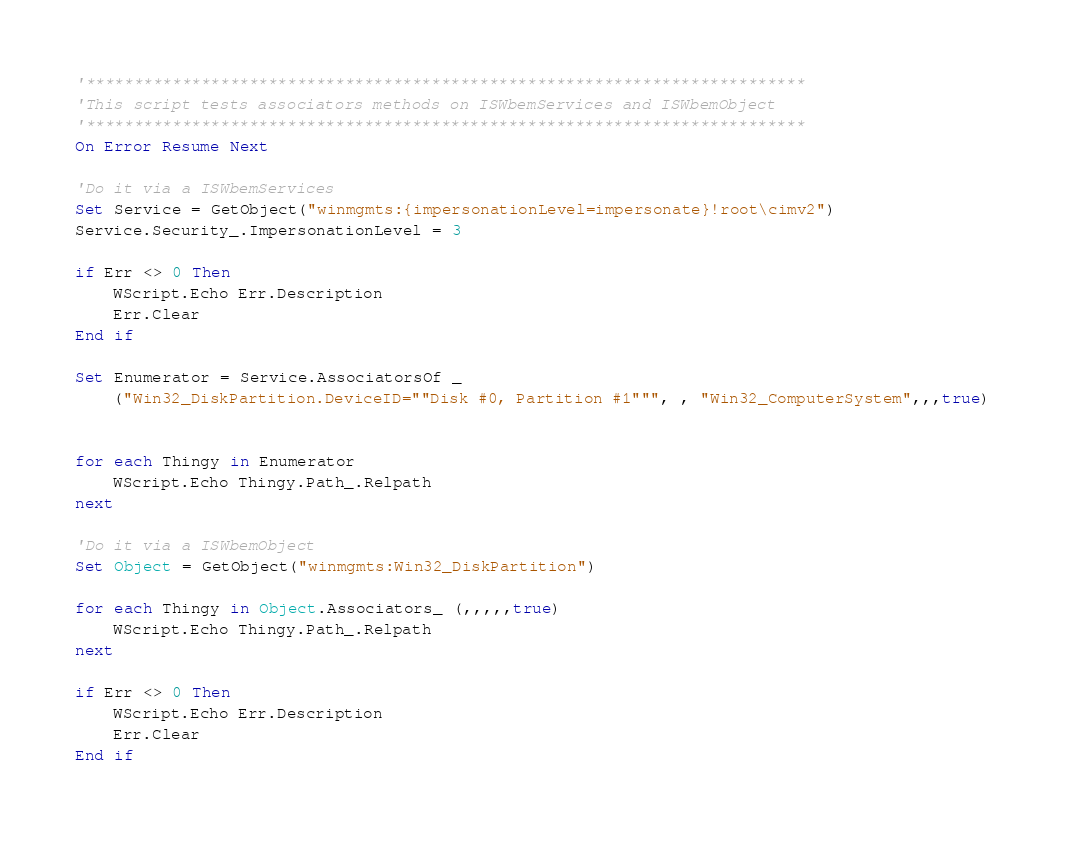<code> <loc_0><loc_0><loc_500><loc_500><_VisualBasic_>'***************************************************************************
'This script tests associators methods on ISWbemServices and ISWbemObject
'***************************************************************************
On Error Resume Next

'Do it via a ISWbemServices
Set Service = GetObject("winmgmts:{impersonationLevel=impersonate}!root\cimv2")
Service.Security_.ImpersonationLevel = 3

if Err <> 0 Then
	WScript.Echo Err.Description
	Err.Clear
End if

Set Enumerator = Service.AssociatorsOf _
	("Win32_DiskPartition.DeviceID=""Disk #0, Partition #1""", , "Win32_ComputerSystem",,,true)


for each Thingy in Enumerator
	WScript.Echo Thingy.Path_.Relpath
next

'Do it via a ISWbemObject
Set Object = GetObject("winmgmts:Win32_DiskPartition")

for each Thingy in Object.Associators_ (,,,,,true)
	WScript.Echo Thingy.Path_.Relpath
next

if Err <> 0 Then
	WScript.Echo Err.Description
	Err.Clear
End if</code> 